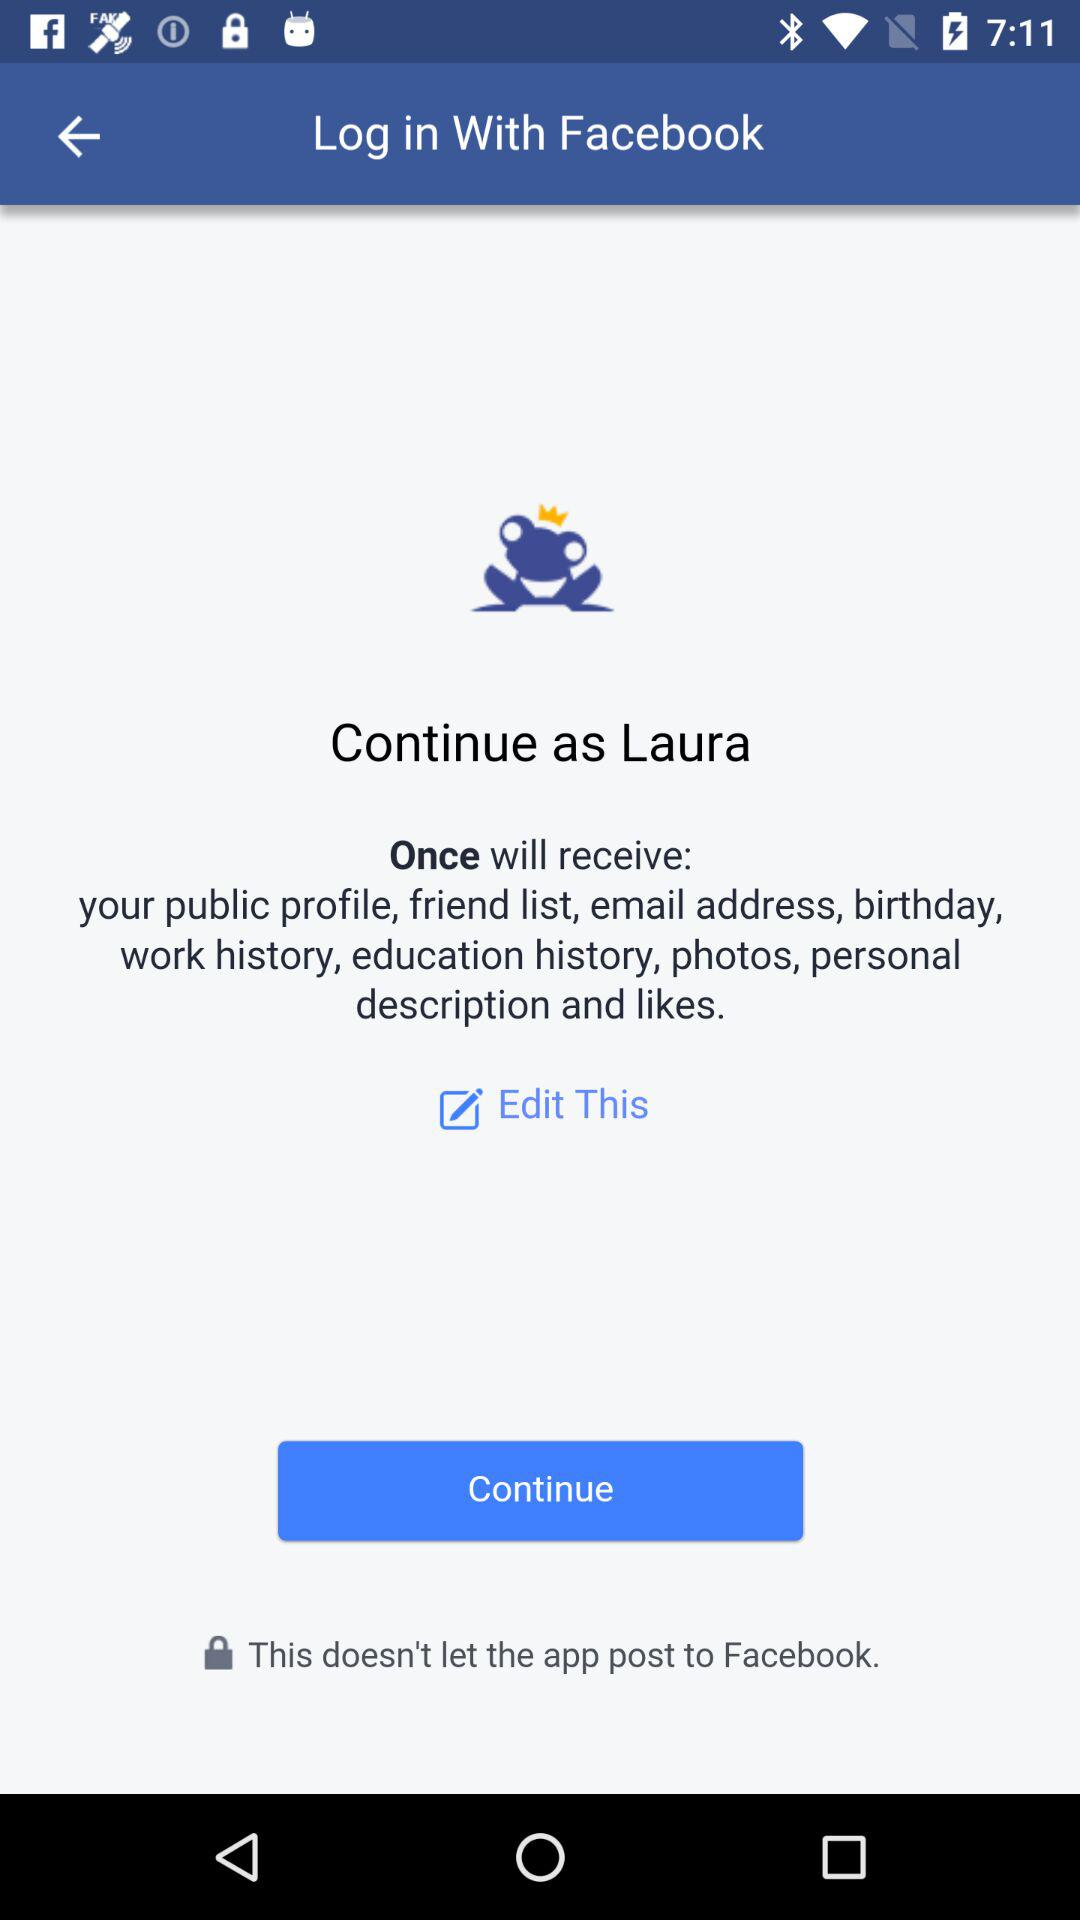What application will receive a public profile, friend list,email address,birthday,work history,education history, photos,personal description, and likes? The application is "Once". 